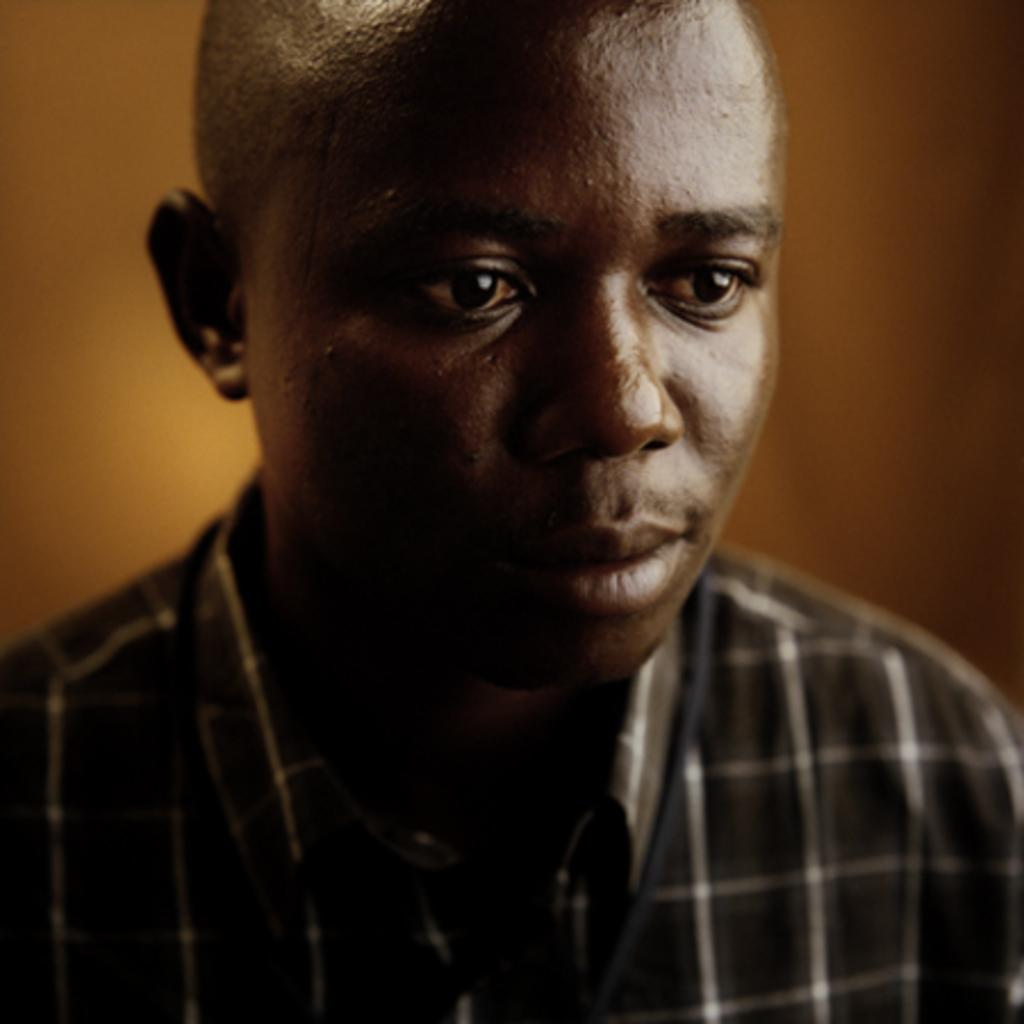Who or what is present in the image? There is a person in the image. What is the person wearing? The person is wearing a brown color shirt. What color is the background of the image? The background of the image is yellow. How many cacti can be seen in the image? There are no cacti present in the image. What type of root system does the person have in the image? The person in the image does not have a root system, as they are not a plant. 